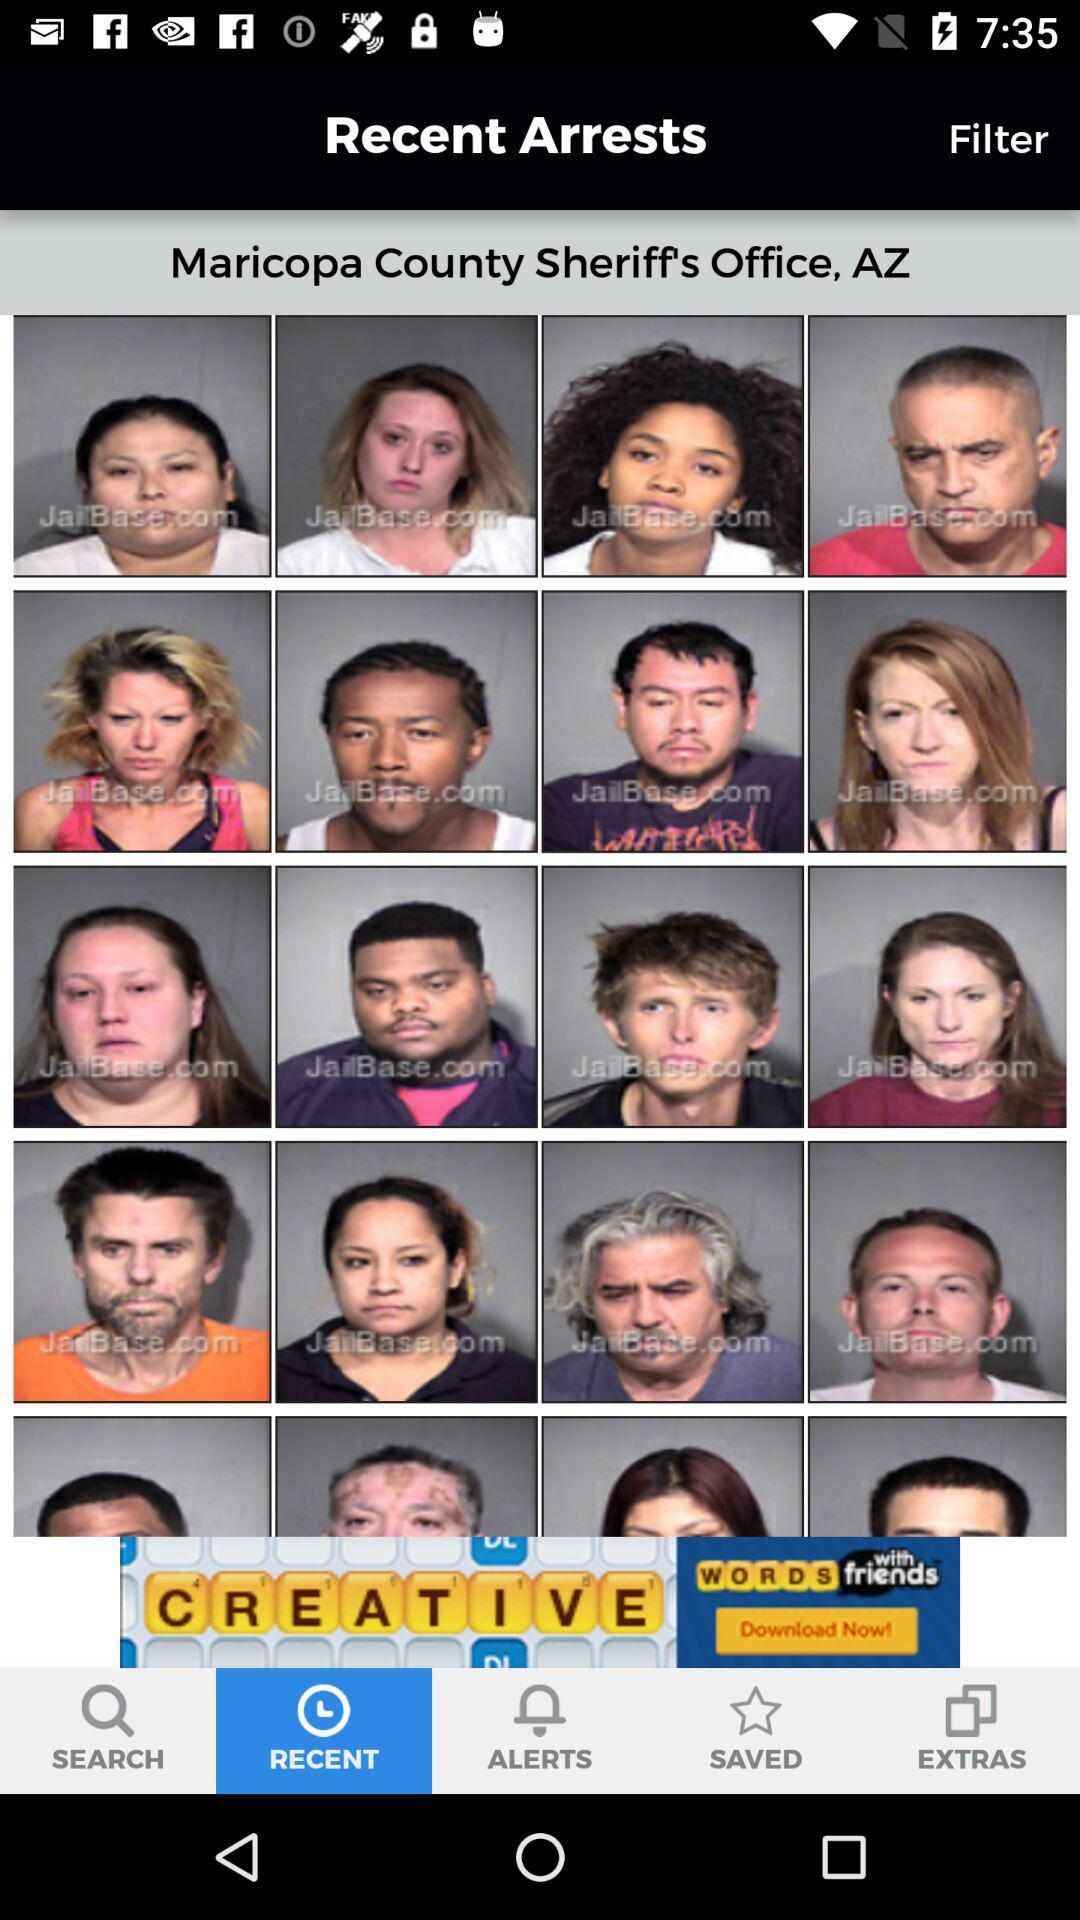Which tab has been selected? The selected tab is "RECENT". 